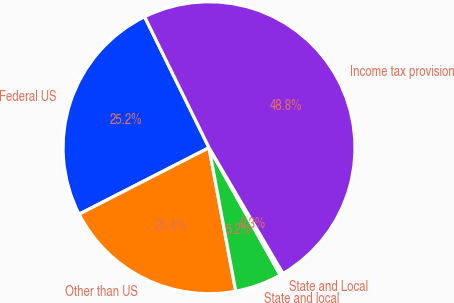<chart> <loc_0><loc_0><loc_500><loc_500><pie_chart><fcel>Federal US<fcel>Other than US<fcel>State and local<fcel>State and Local<fcel>Income tax provision<nl><fcel>25.25%<fcel>20.4%<fcel>5.19%<fcel>0.34%<fcel>48.82%<nl></chart> 